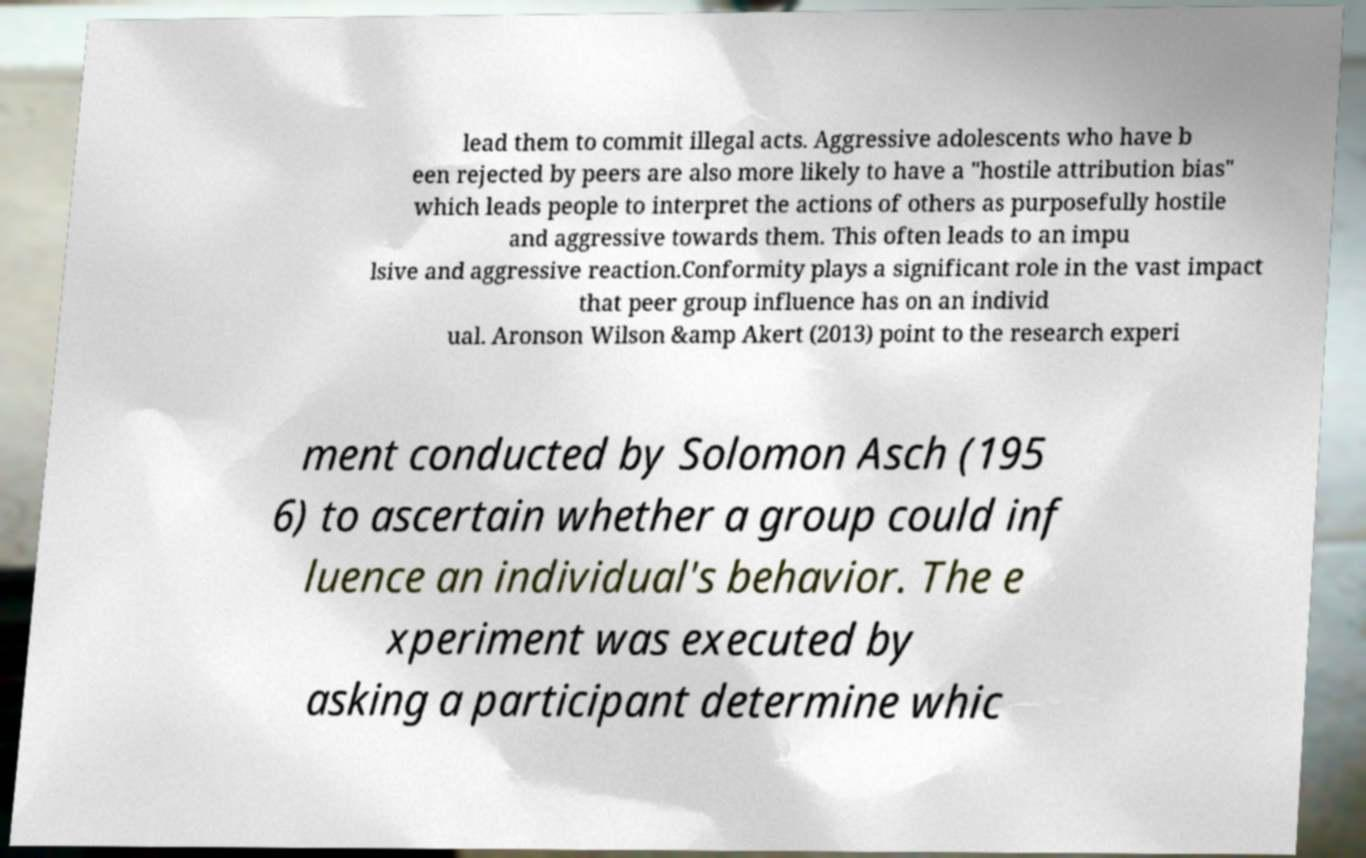There's text embedded in this image that I need extracted. Can you transcribe it verbatim? lead them to commit illegal acts. Aggressive adolescents who have b een rejected by peers are also more likely to have a "hostile attribution bias" which leads people to interpret the actions of others as purposefully hostile and aggressive towards them. This often leads to an impu lsive and aggressive reaction.Conformity plays a significant role in the vast impact that peer group influence has on an individ ual. Aronson Wilson &amp Akert (2013) point to the research experi ment conducted by Solomon Asch (195 6) to ascertain whether a group could inf luence an individual's behavior. The e xperiment was executed by asking a participant determine whic 